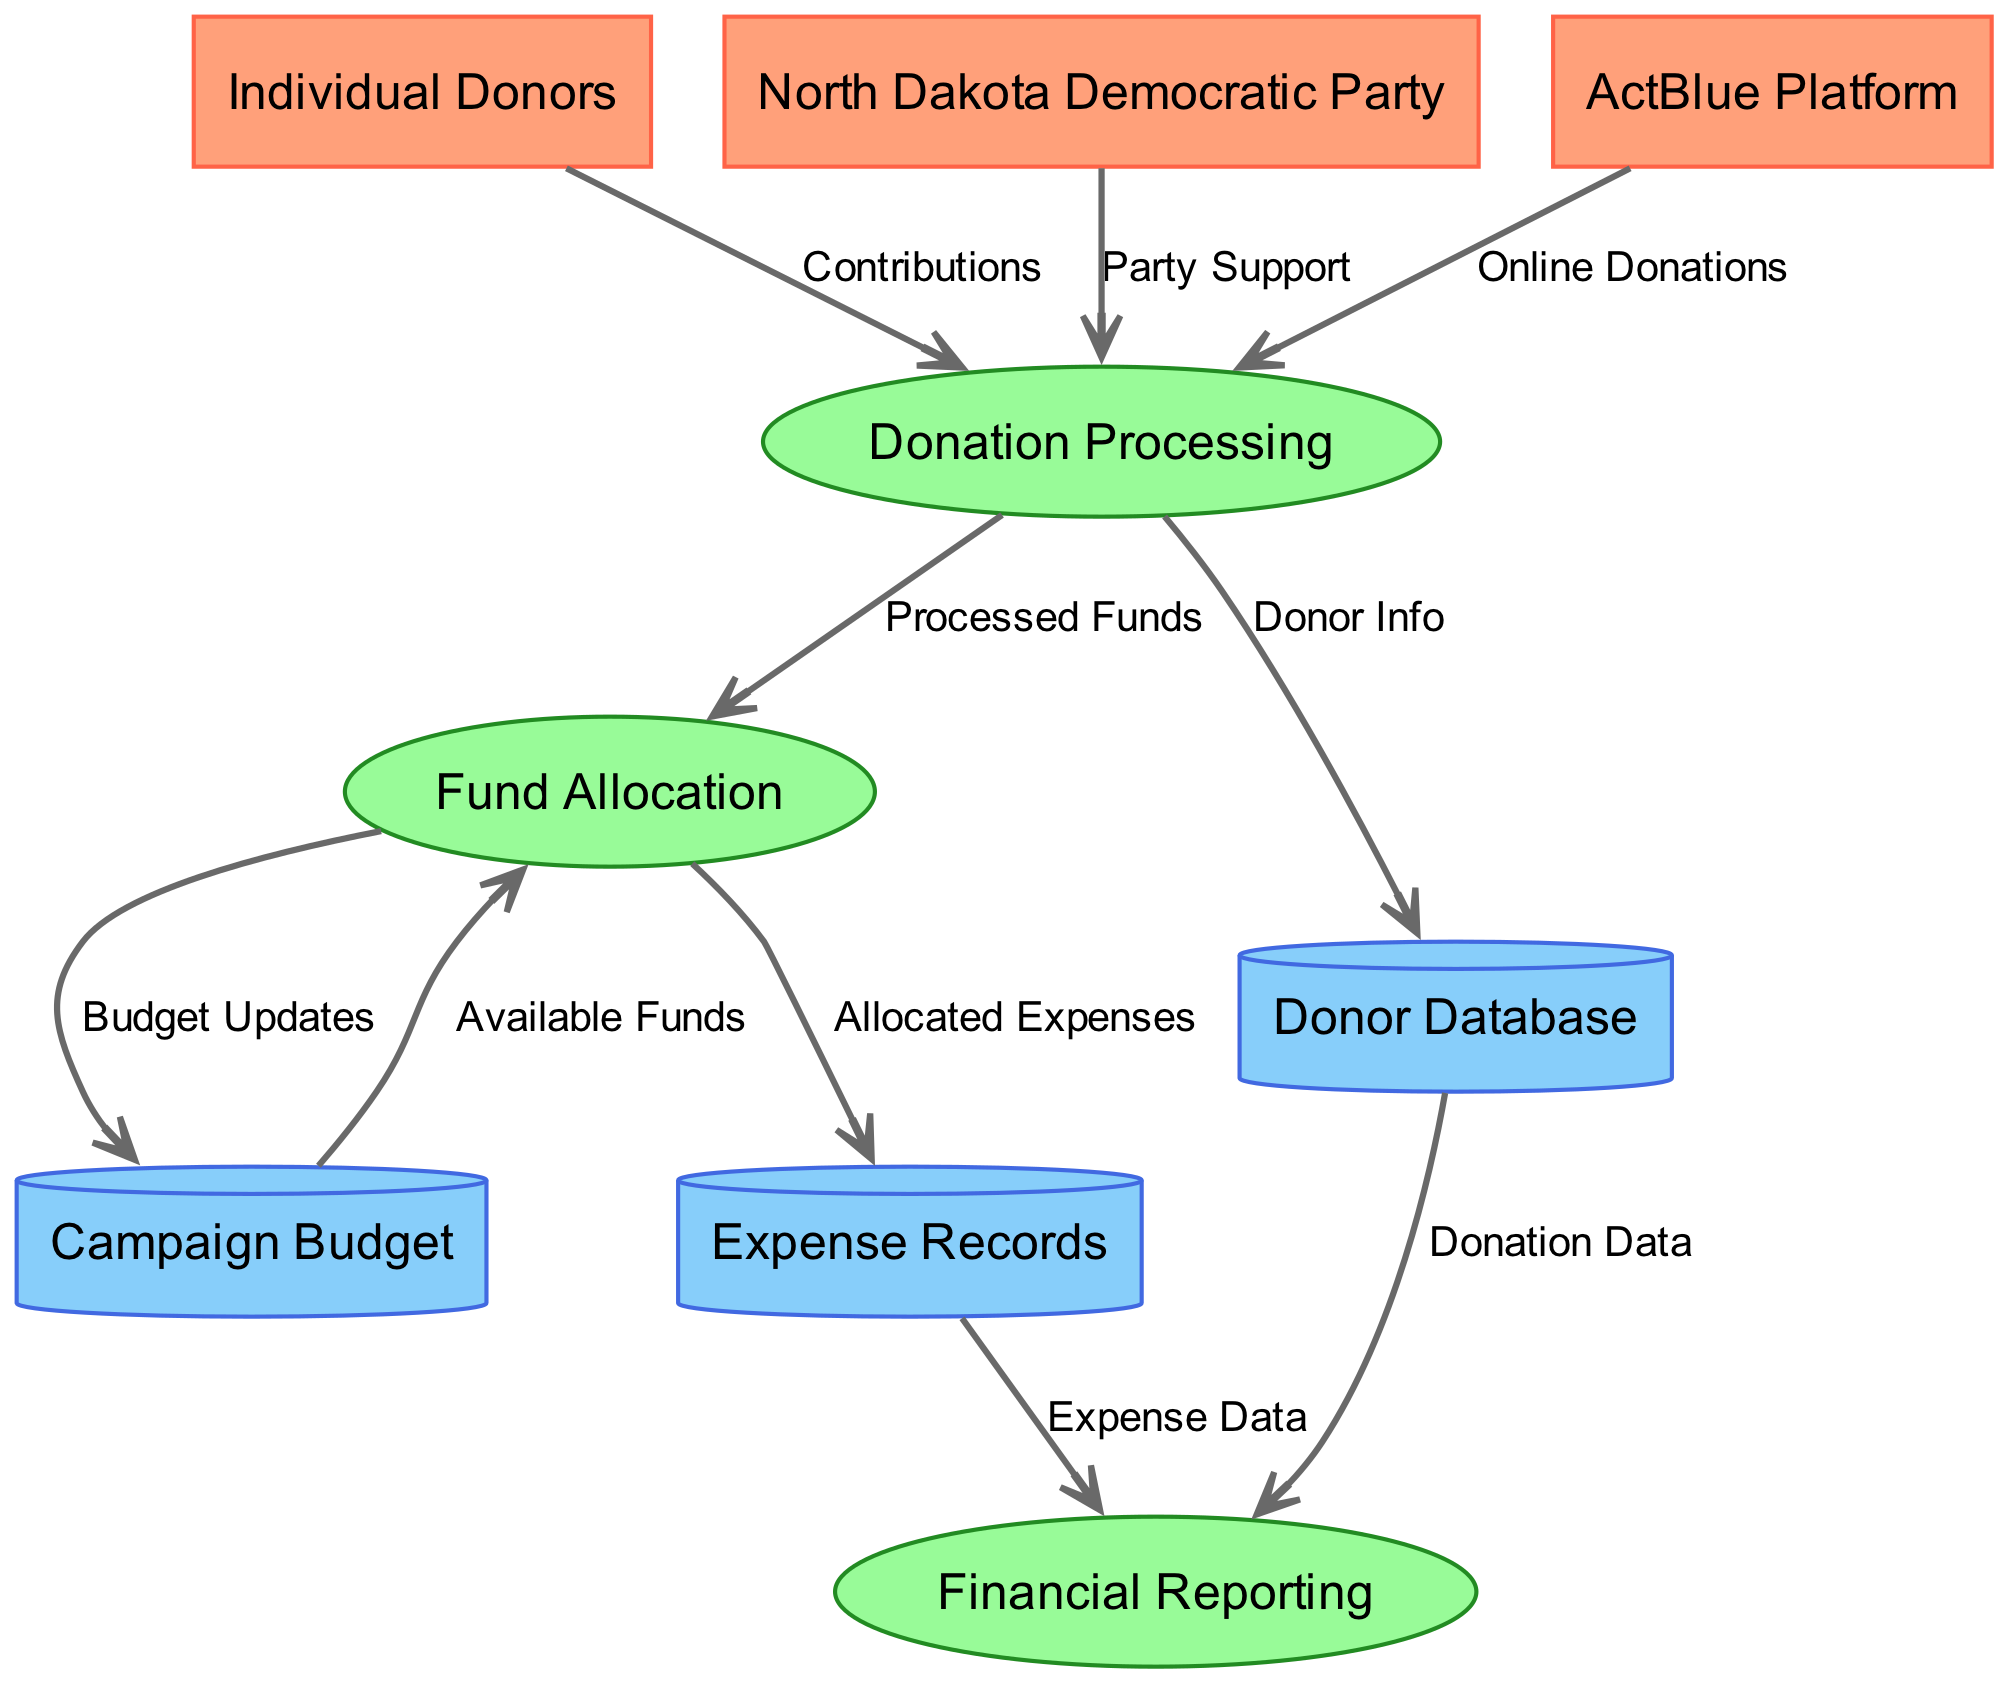What are the external entities in the diagram? The external entities are listed in the diagram as individual components that interact with the campaign fundraising process. They include "Individual Donors," "North Dakota Democratic Party," and "ActBlue Platform."
Answer: Individual Donors, North Dakota Democratic Party, ActBlue Platform How many processes are represented in the diagram? The diagram contains three processes which are "Donation Processing," "Fund Allocation," and "Financial Reporting." By counting them, we can confirm that the number is three.
Answer: 3 What data flows from Donation Processing to the Donor Database? The data that flows from Donation Processing to the Donor Database is labeled "Donor Info." This represents the information collected during the donation process that is stored for future reference.
Answer: Donor Info Which data store receives "Allocated Expenses" from Fund Allocation? The data store that receives "Allocated Expenses" from Fund Allocation is the "Expense Records." This indicates that the funds allocated for various expenses are recorded in this data store.
Answer: Expense Records What incoming data flow is labeled "Online Donations"? The incoming data flow labeled "Online Donations" comes from "ActBlue Platform." This represents funds collected through online platforms associated with the fundraising campaign.
Answer: ActBlue Platform Which process is primarily responsible for processing donor contributions? The process primarily responsible for processing donor contributions is "Donation Processing." This is where contributions from external entities are initially handled and logged into the system.
Answer: Donation Processing What type of information does the Financial Reporting process receive from the Expense Records? The Financial Reporting process receives "Expense Data" from the Expense Records. This suggests that it utilizes the recorded expenses to generate financial reports.
Answer: Expense Data What initiates the flow of "Processed Funds"? The flow of "Processed Funds" is initiated by "Donation Processing." This indicates that the funds collected are handled here before being allocated for various activities in the campaign.
Answer: Donation Processing What flows from Fund Allocation to the Campaign Budget? The flow from Fund Allocation to the Campaign Budget is labeled "Budget Updates." This represents the updates made to the campaign budget based on the funds allocated for upcoming activities.
Answer: Budget Updates 